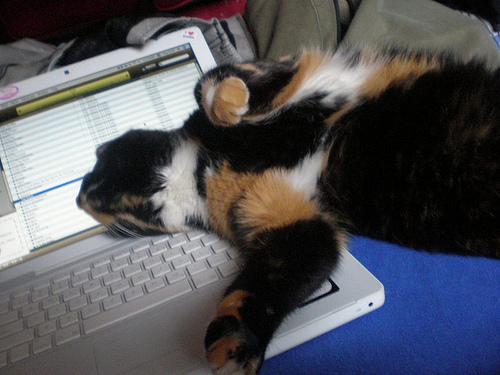What is on top of the computer?
Be succinct. Cat. Is the cat agitated?
Concise answer only. No. What brand of computer is this?
Give a very brief answer. Apple. 